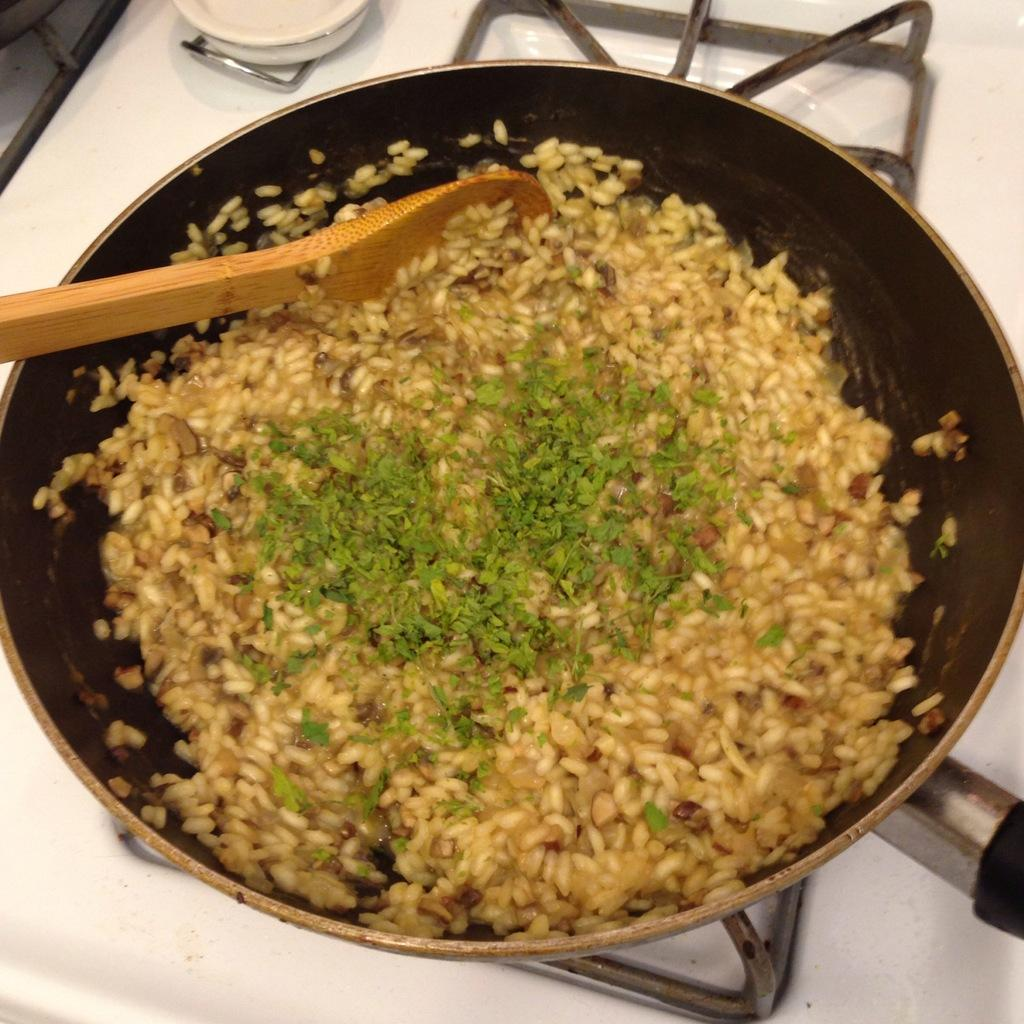What is the main object in the image? There is a pan in the image. What is happening with the pan? Food is being prepared in the pan. Where is the pan located? The pan is on a stove. What utensil is present in the image? There is a spoon present in the image. Can you see a hydrant in the image? No, there is no hydrant present in the image. What type of spark can be seen coming from the pan in the image? There is no spark visible in the image; the pan is simply on a stove with food being prepared. 